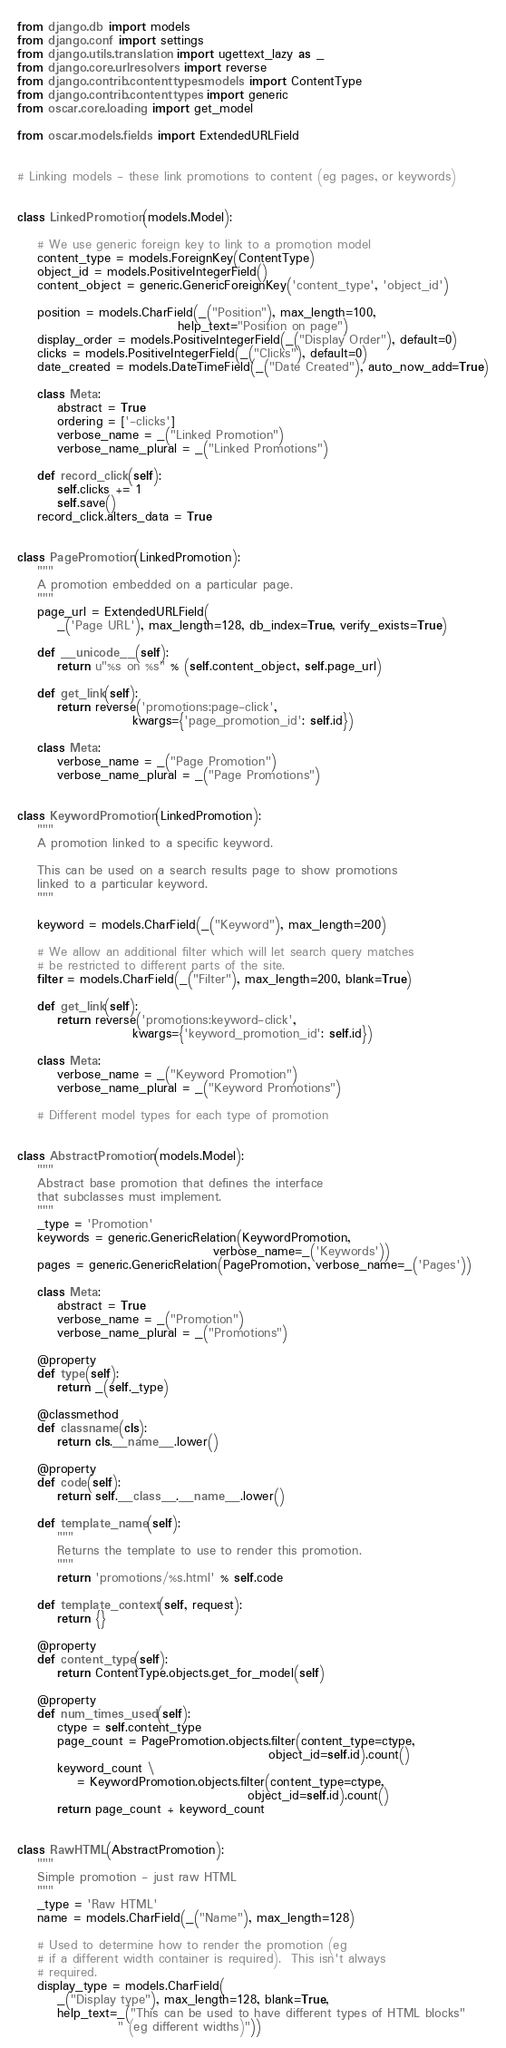<code> <loc_0><loc_0><loc_500><loc_500><_Python_>from django.db import models
from django.conf import settings
from django.utils.translation import ugettext_lazy as _
from django.core.urlresolvers import reverse
from django.contrib.contenttypes.models import ContentType
from django.contrib.contenttypes import generic
from oscar.core.loading import get_model

from oscar.models.fields import ExtendedURLField


# Linking models - these link promotions to content (eg pages, or keywords)


class LinkedPromotion(models.Model):

    # We use generic foreign key to link to a promotion model
    content_type = models.ForeignKey(ContentType)
    object_id = models.PositiveIntegerField()
    content_object = generic.GenericForeignKey('content_type', 'object_id')

    position = models.CharField(_("Position"), max_length=100,
                                help_text="Position on page")
    display_order = models.PositiveIntegerField(_("Display Order"), default=0)
    clicks = models.PositiveIntegerField(_("Clicks"), default=0)
    date_created = models.DateTimeField(_("Date Created"), auto_now_add=True)

    class Meta:
        abstract = True
        ordering = ['-clicks']
        verbose_name = _("Linked Promotion")
        verbose_name_plural = _("Linked Promotions")

    def record_click(self):
        self.clicks += 1
        self.save()
    record_click.alters_data = True


class PagePromotion(LinkedPromotion):
    """
    A promotion embedded on a particular page.
    """
    page_url = ExtendedURLField(
        _('Page URL'), max_length=128, db_index=True, verify_exists=True)

    def __unicode__(self):
        return u"%s on %s" % (self.content_object, self.page_url)

    def get_link(self):
        return reverse('promotions:page-click',
                       kwargs={'page_promotion_id': self.id})

    class Meta:
        verbose_name = _("Page Promotion")
        verbose_name_plural = _("Page Promotions")


class KeywordPromotion(LinkedPromotion):
    """
    A promotion linked to a specific keyword.

    This can be used on a search results page to show promotions
    linked to a particular keyword.
    """

    keyword = models.CharField(_("Keyword"), max_length=200)

    # We allow an additional filter which will let search query matches
    # be restricted to different parts of the site.
    filter = models.CharField(_("Filter"), max_length=200, blank=True)

    def get_link(self):
        return reverse('promotions:keyword-click',
                       kwargs={'keyword_promotion_id': self.id})

    class Meta:
        verbose_name = _("Keyword Promotion")
        verbose_name_plural = _("Keyword Promotions")

    # Different model types for each type of promotion


class AbstractPromotion(models.Model):
    """
    Abstract base promotion that defines the interface
    that subclasses must implement.
    """
    _type = 'Promotion'
    keywords = generic.GenericRelation(KeywordPromotion,
                                       verbose_name=_('Keywords'))
    pages = generic.GenericRelation(PagePromotion, verbose_name=_('Pages'))

    class Meta:
        abstract = True
        verbose_name = _("Promotion")
        verbose_name_plural = _("Promotions")

    @property
    def type(self):
        return _(self._type)

    @classmethod
    def classname(cls):
        return cls.__name__.lower()

    @property
    def code(self):
        return self.__class__.__name__.lower()

    def template_name(self):
        """
        Returns the template to use to render this promotion.
        """
        return 'promotions/%s.html' % self.code

    def template_context(self, request):
        return {}

    @property
    def content_type(self):
        return ContentType.objects.get_for_model(self)

    @property
    def num_times_used(self):
        ctype = self.content_type
        page_count = PagePromotion.objects.filter(content_type=ctype,
                                                  object_id=self.id).count()
        keyword_count \
            = KeywordPromotion.objects.filter(content_type=ctype,
                                              object_id=self.id).count()
        return page_count + keyword_count


class RawHTML(AbstractPromotion):
    """
    Simple promotion - just raw HTML
    """
    _type = 'Raw HTML'
    name = models.CharField(_("Name"), max_length=128)

    # Used to determine how to render the promotion (eg
    # if a different width container is required).  This isn't always
    # required.
    display_type = models.CharField(
        _("Display type"), max_length=128, blank=True,
        help_text=_("This can be used to have different types of HTML blocks"
                    " (eg different widths)"))</code> 